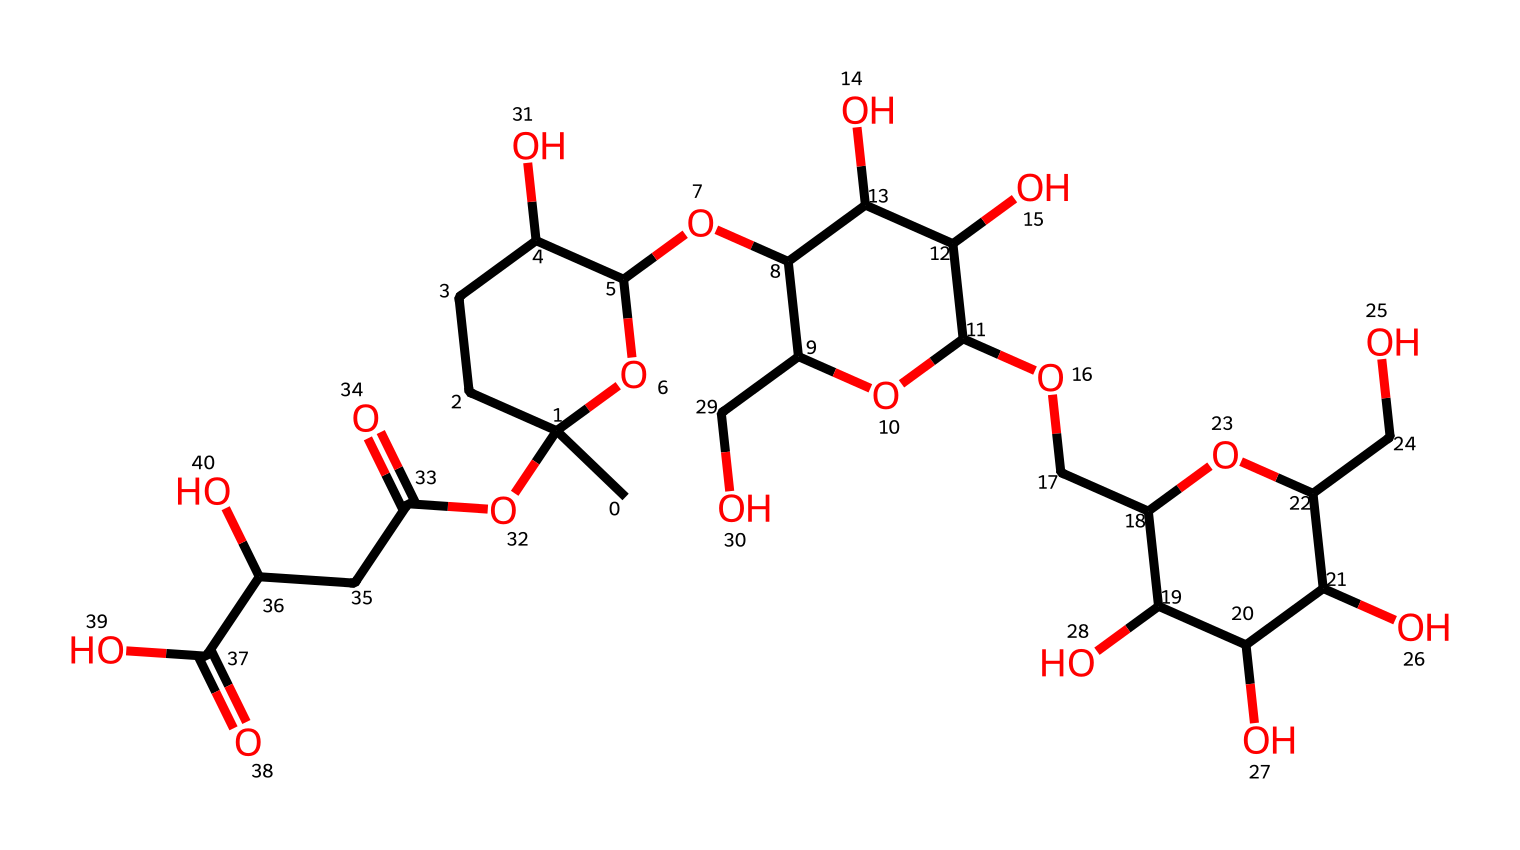What is the primary component of xanthan gum? The structure indicates a polysaccharide made up primarily of sugar units. This is characteristic of xanthan gum, which is a polysaccharide used for its thickening properties.
Answer: polysaccharide How many carbon atoms are in the molecule? By examining the SMILES representation, we can count the "C" characters, which represent carbon atoms. Upon counting, there are 33 carbon atoms.
Answer: 33 What properties of xanthan gum contribute to its use as a thickener in food? Xanthan gum has a molecular structure with a high degree of branching and hydrogen bonding potential, making it viscous when hydrated. This property is essential for its thickening ability.
Answer: viscosity What type of fluid behavior does xanthan gum exhibit when shear force is applied? Xanthan gum solutions are known to exhibit shear-thinning behavior, meaning their viscosity decreases when shear force is applied. This is crucial for applications in the food industry where ease of mixing is required.
Answer: shear-thinning What specific industrial applications utilize xanthan gum? Xanthan gum is widely used in food products such as salad dressings, sauces, and gluten-free baked goods due to its thickening and stabilizing properties.
Answer: food products How does the molecular arrangement of xanthan gum affect its solubility in water? The presence of multiple hydroxyl (OH) groups in the structure enhances its solubility in water, allowing the polymer to absorb water and swell, forming a gel-like consistency.
Answer: enhances solubility 